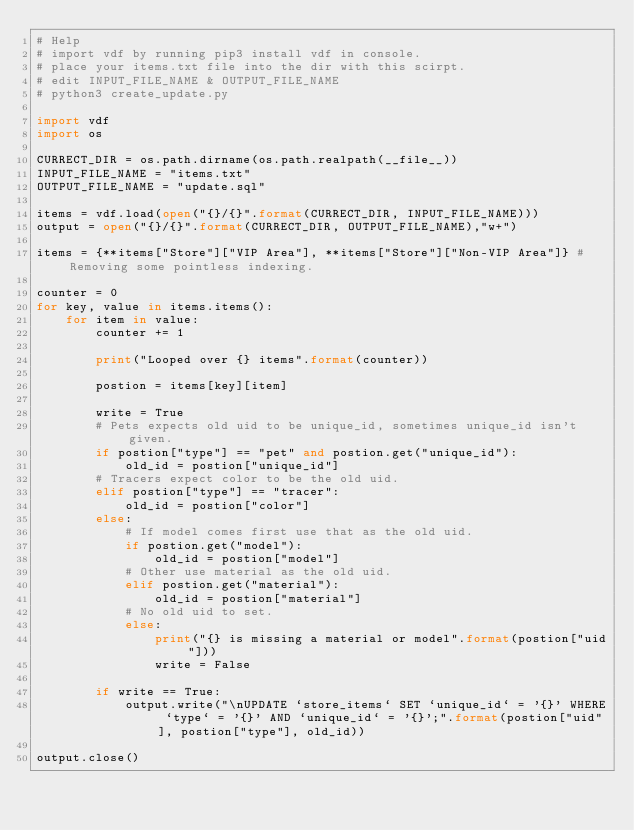<code> <loc_0><loc_0><loc_500><loc_500><_Python_># Help
# import vdf by running pip3 install vdf in console.
# place your items.txt file into the dir with this scirpt.
# edit INPUT_FILE_NAME & OUTPUT_FILE_NAME
# python3 create_update.py

import vdf
import os

CURRECT_DIR = os.path.dirname(os.path.realpath(__file__))
INPUT_FILE_NAME = "items.txt"
OUTPUT_FILE_NAME = "update.sql"

items = vdf.load(open("{}/{}".format(CURRECT_DIR, INPUT_FILE_NAME)))
output = open("{}/{}".format(CURRECT_DIR, OUTPUT_FILE_NAME),"w+")

items = {**items["Store"]["VIP Area"], **items["Store"]["Non-VIP Area"]} # Removing some pointless indexing.

counter = 0
for key, value in items.items():
    for item in value:
        counter += 1

        print("Looped over {} items".format(counter))

        postion = items[key][item]

        write = True
        # Pets expects old uid to be unique_id, sometimes unique_id isn't given.
        if postion["type"] == "pet" and postion.get("unique_id"):
            old_id = postion["unique_id"]
        # Tracers expect color to be the old uid.
        elif postion["type"] == "tracer":
            old_id = postion["color"]
        else:
            # If model comes first use that as the old uid.
            if postion.get("model"):
                old_id = postion["model"]
            # Other use material as the old uid.
            elif postion.get("material"):
                old_id = postion["material"]
            # No old uid to set.
            else:
                print("{} is missing a material or model".format(postion["uid"]))
                write = False

        if write == True:
            output.write("\nUPDATE `store_items` SET `unique_id` = '{}' WHERE `type` = '{}' AND `unique_id` = '{}';".format(postion["uid"], postion["type"], old_id))

output.close()
</code> 